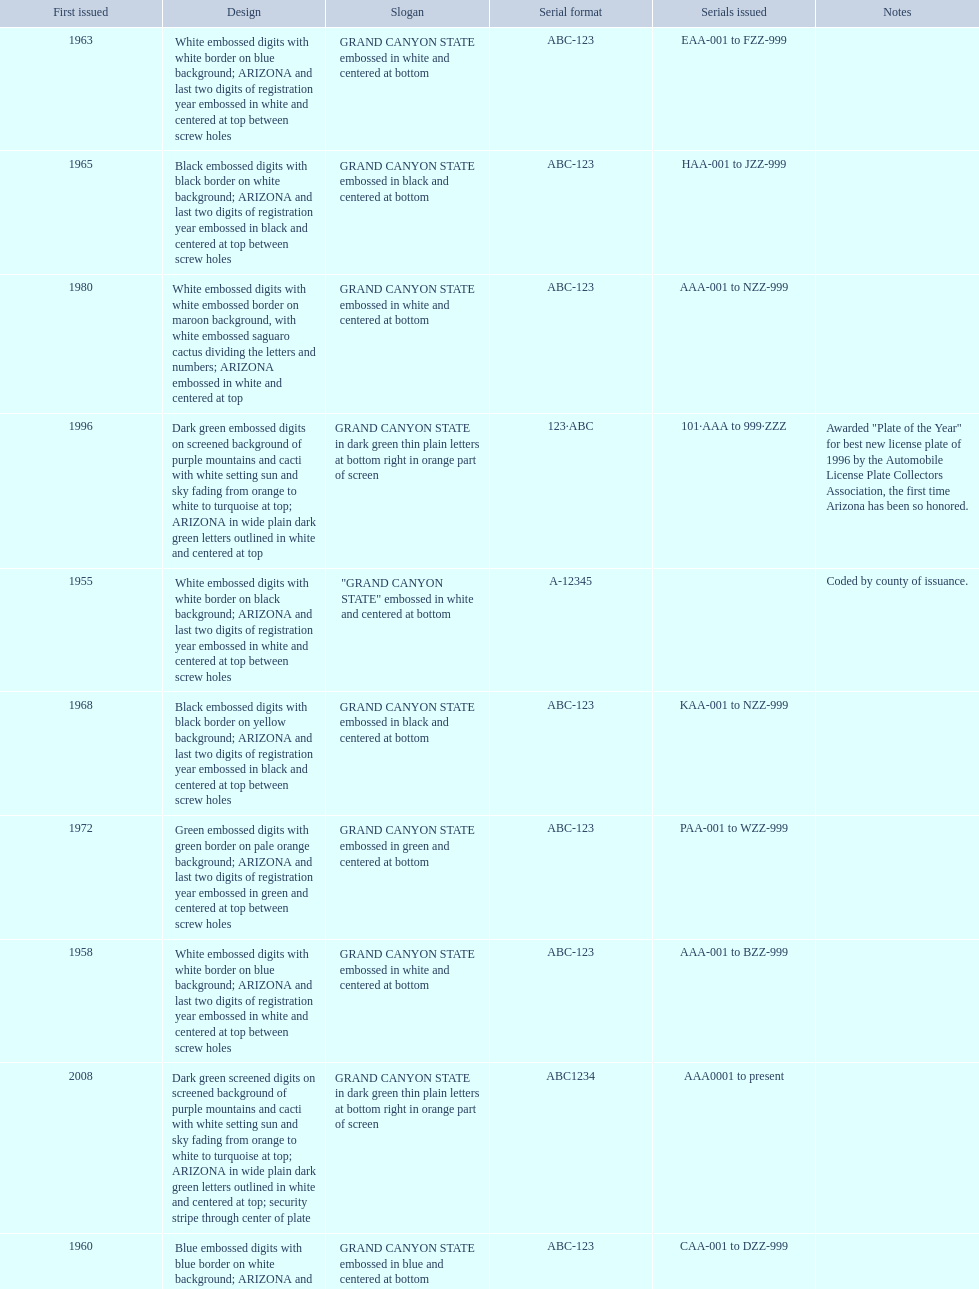What was year was the first arizona license plate made? 1955. 